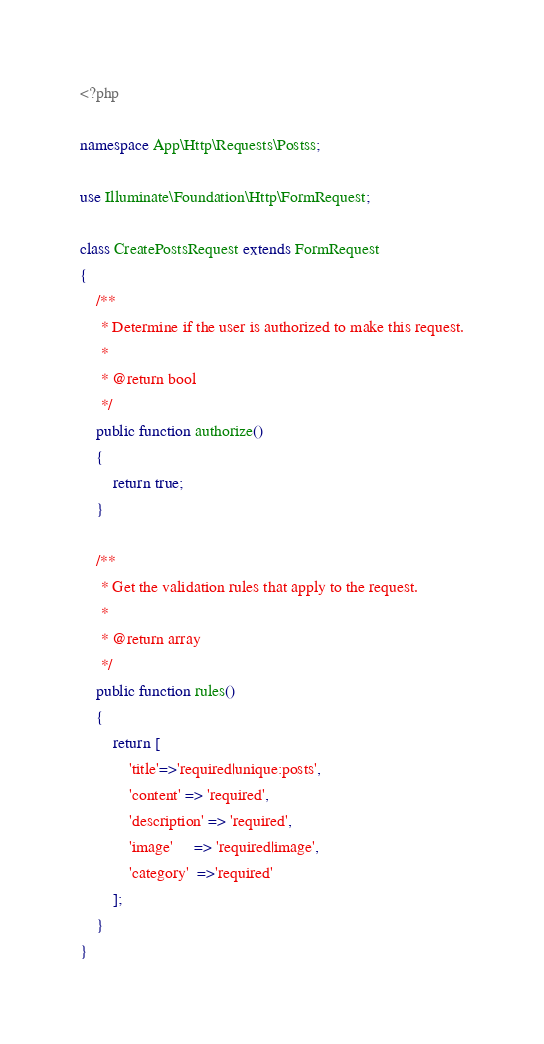Convert code to text. <code><loc_0><loc_0><loc_500><loc_500><_PHP_><?php

namespace App\Http\Requests\Postss;

use Illuminate\Foundation\Http\FormRequest;

class CreatePostsRequest extends FormRequest
{
    /**
     * Determine if the user is authorized to make this request.
     *
     * @return bool
     */
    public function authorize()
    {
        return true;
    }

    /**
     * Get the validation rules that apply to the request.
     *
     * @return array
     */
    public function rules()
    {
        return [ 
            'title'=>'required|unique:posts',
            'content' => 'required',
            'description' => 'required',
            'image'     => 'required|image',
            'category'  =>'required'
        ];
    }
}
</code> 